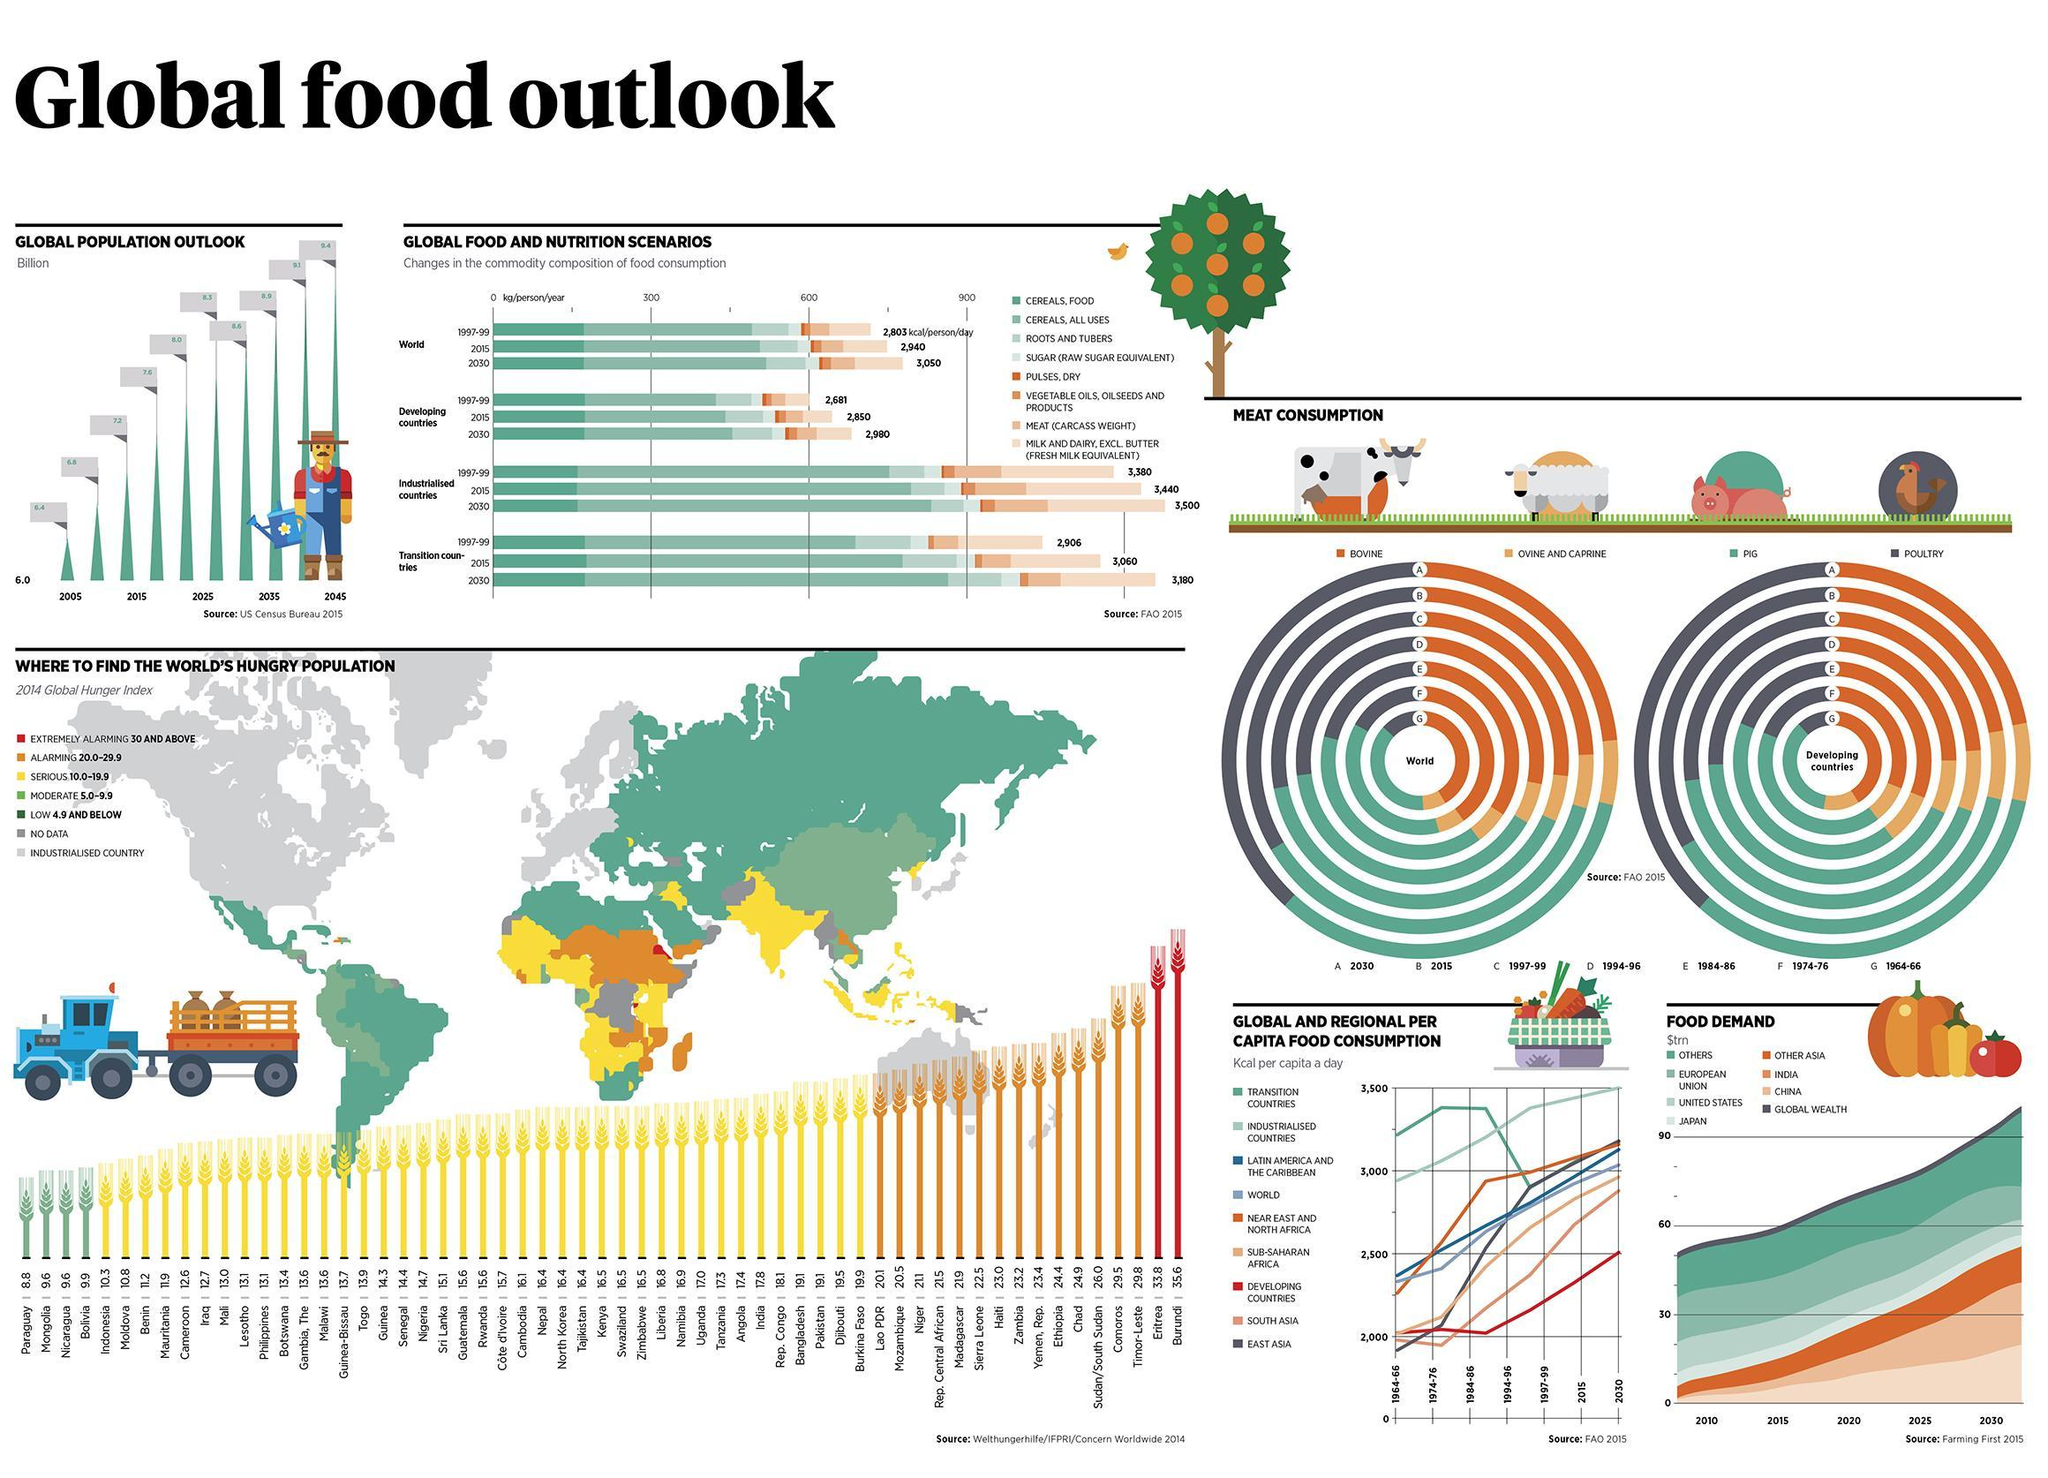What will be the predicted increase in food consumption in transition countries in KCal from 1999-2030?
Answer the question with a short phrase. 274 KCal/person/day Which two countries have alarming rates of hunger ? Eritrea, Burundi Which countries show a steep drop in the KCal per capita a day? Transition countries How much more will a person in an industrialized country consume in KCal in comparison to a person living in a developing county in 2030? 520 Kcal/person/day 